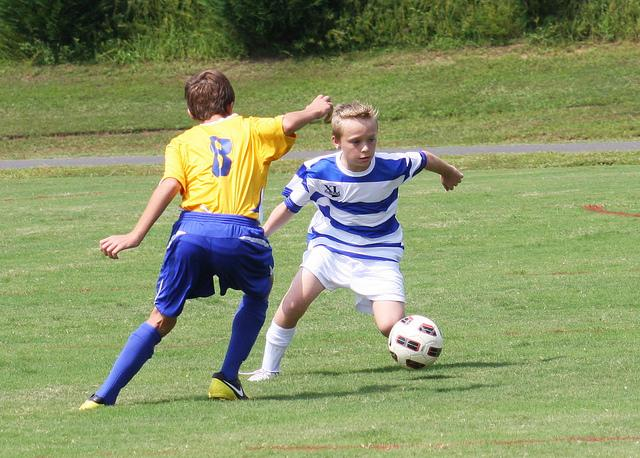What is the boy in blue and white trying to do?

Choices:
A) backflip
B) kick ball
C) tackle boy
D) grab ball kick ball 